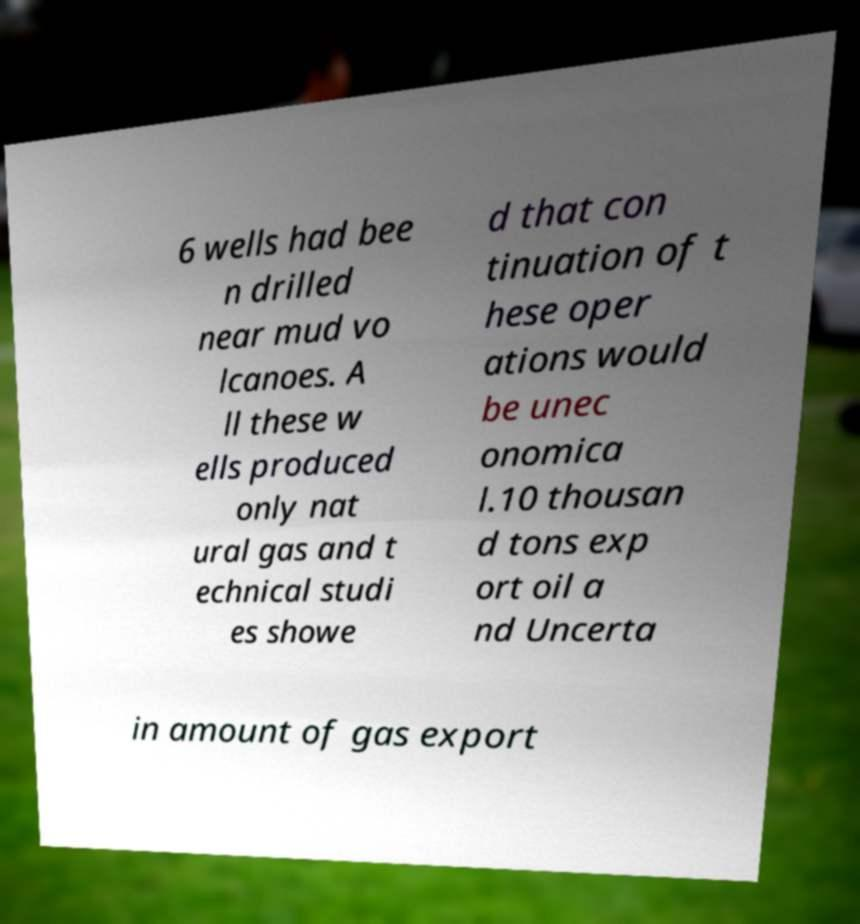Could you extract and type out the text from this image? 6 wells had bee n drilled near mud vo lcanoes. A ll these w ells produced only nat ural gas and t echnical studi es showe d that con tinuation of t hese oper ations would be unec onomica l.10 thousan d tons exp ort oil a nd Uncerta in amount of gas export 